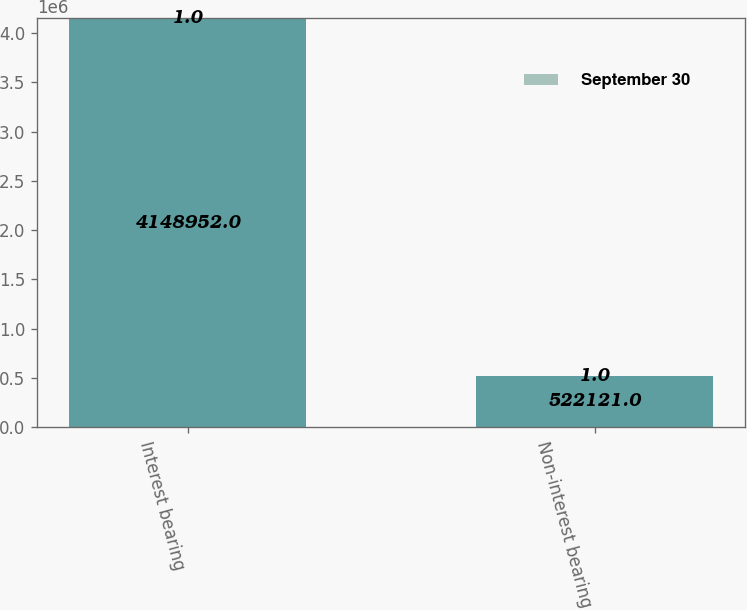<chart> <loc_0><loc_0><loc_500><loc_500><stacked_bar_chart><ecel><fcel>Interest bearing<fcel>Non-interest bearing<nl><fcel>nan<fcel>4.14895e+06<fcel>522121<nl><fcel>September 30<fcel>1<fcel>1<nl></chart> 